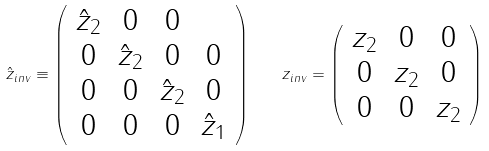Convert formula to latex. <formula><loc_0><loc_0><loc_500><loc_500>\hat { z } _ { i n v } \equiv \left ( \begin{array} { c c c c } \hat { z } _ { 2 } & 0 & 0 \\ 0 & \hat { z } _ { 2 } & 0 & 0 \\ 0 & 0 & \hat { z } _ { 2 } & 0 \\ 0 & 0 & 0 & \hat { z } _ { 1 } \end{array} \right ) \quad z _ { i n v } = \left ( \begin{array} { c c c } z _ { 2 } & 0 & 0 \\ 0 & z _ { 2 } & 0 \\ 0 & 0 & z _ { 2 } \end{array} \right )</formula> 